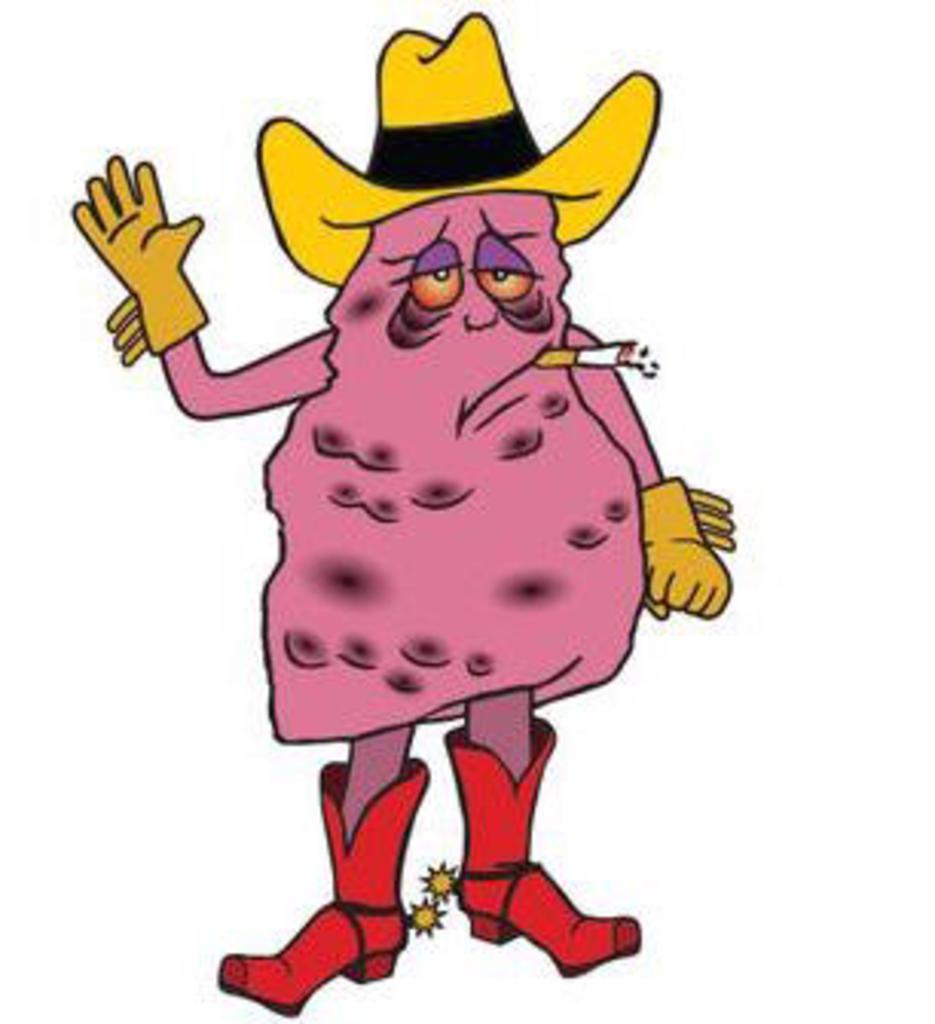What type of character is depicted in the image? There is a cartoon character in the image. What color are the boots worn by the cartoon character? The cartoon character is wearing red boots. What color is the hat worn by the cartoon character? The cartoon character is wearing a yellow hat. What type of clothing is the cartoon character wearing on their hands? The cartoon character is wearing gloves. What type of soap is the cartoon character using in the image? There is no soap present in the image; the cartoon character is smoking a cigar. 